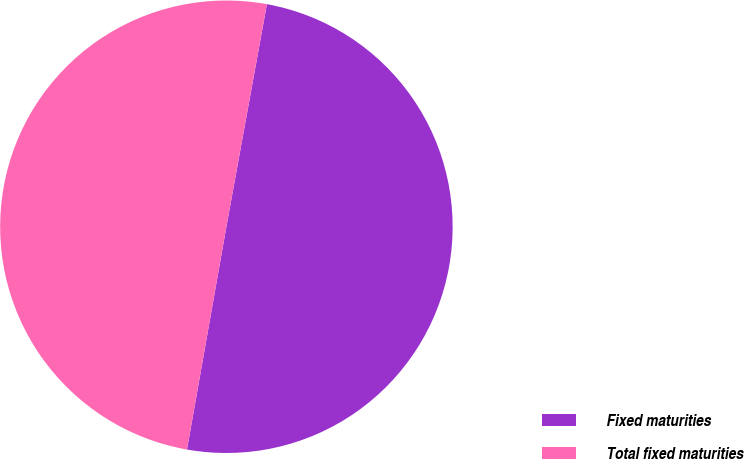<chart> <loc_0><loc_0><loc_500><loc_500><pie_chart><fcel>Fixed maturities<fcel>Total fixed maturities<nl><fcel>49.92%<fcel>50.08%<nl></chart> 